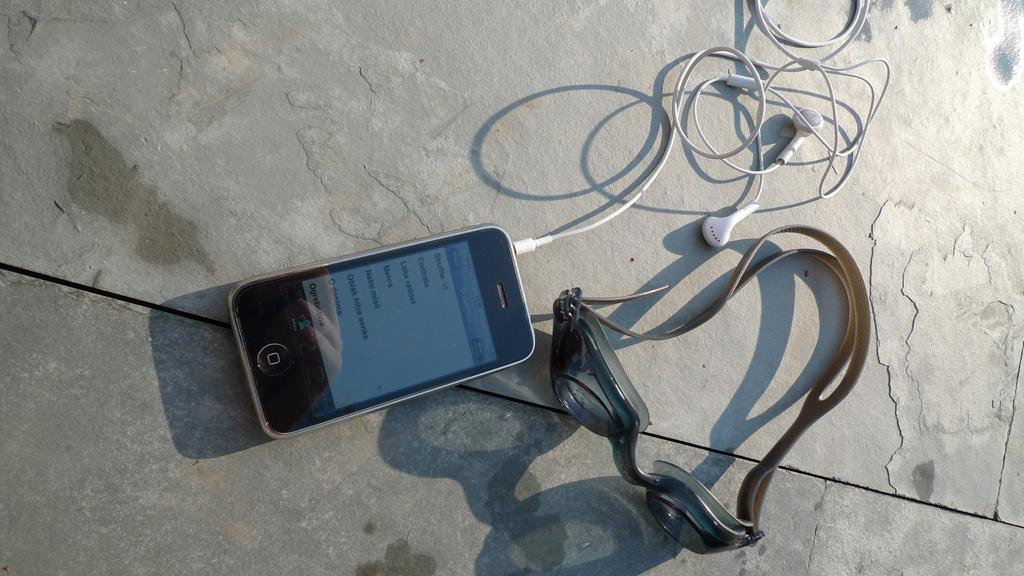<image>
Describe the image concisely. A cellphone screen contains the function Shuffle, among other selections. 